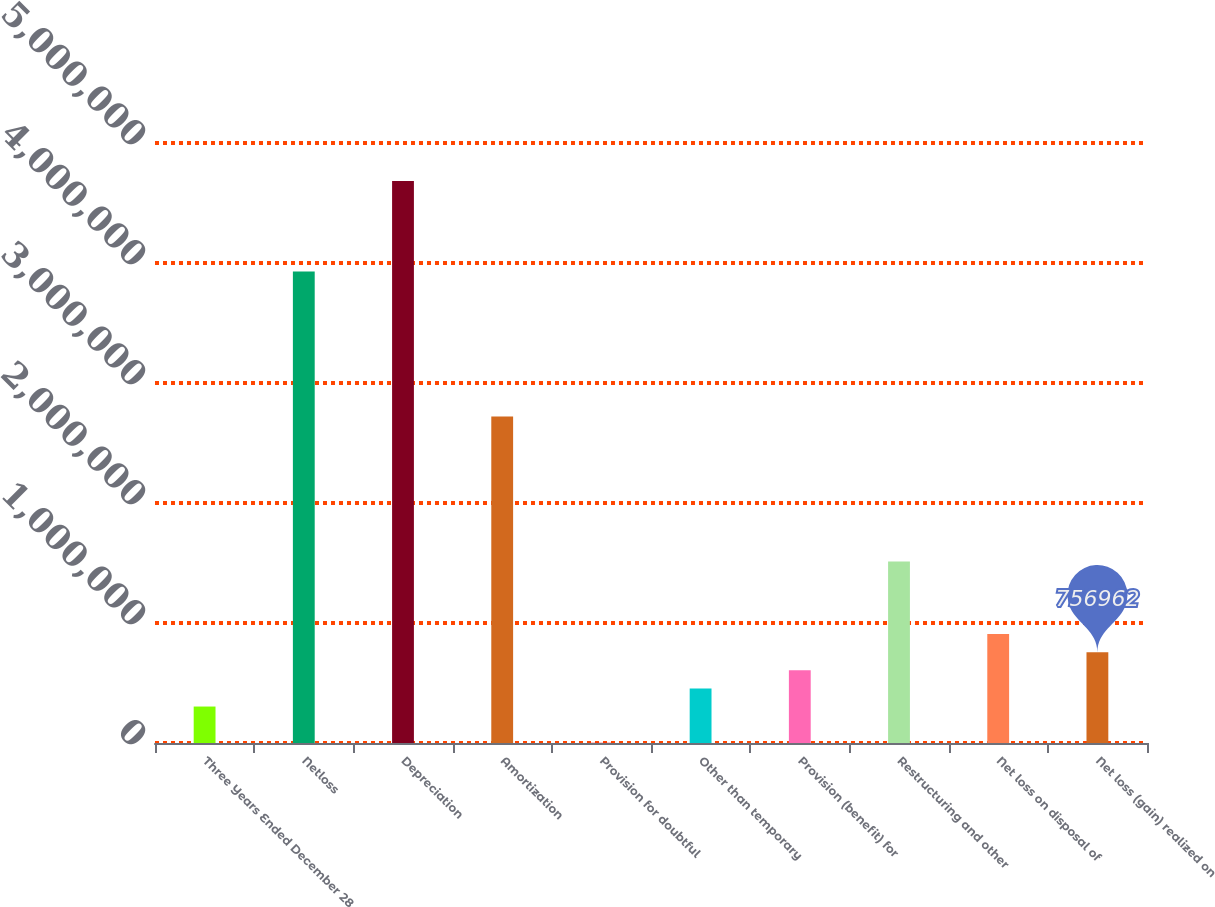Convert chart. <chart><loc_0><loc_0><loc_500><loc_500><bar_chart><fcel>Three Years Ended December 28<fcel>Netloss<fcel>Depreciation<fcel>Amortization<fcel>Provision for doubtful<fcel>Other than temporary<fcel>Provision (benefit) for<fcel>Restructuring and other<fcel>Net loss on disposal of<fcel>Net loss (gain) realized on<nl><fcel>303883<fcel>3.92851e+06<fcel>4.68364e+06<fcel>2.7203e+06<fcel>1831<fcel>454910<fcel>605936<fcel>1.51209e+06<fcel>907988<fcel>756962<nl></chart> 